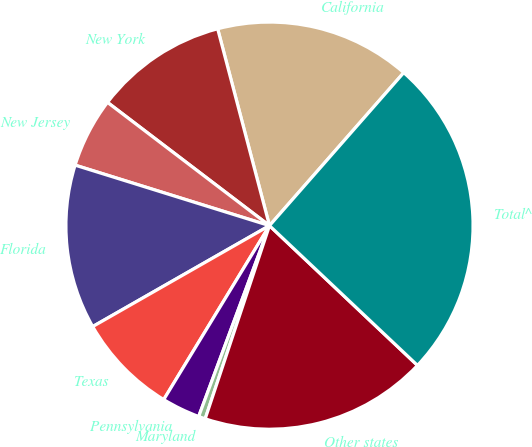<chart> <loc_0><loc_0><loc_500><loc_500><pie_chart><fcel>California<fcel>New York<fcel>New Jersey<fcel>Florida<fcel>Texas<fcel>Pennsylvania<fcel>Maryland<fcel>Other states<fcel>Total^<nl><fcel>15.56%<fcel>10.55%<fcel>5.55%<fcel>13.06%<fcel>8.05%<fcel>3.04%<fcel>0.54%<fcel>18.07%<fcel>25.58%<nl></chart> 